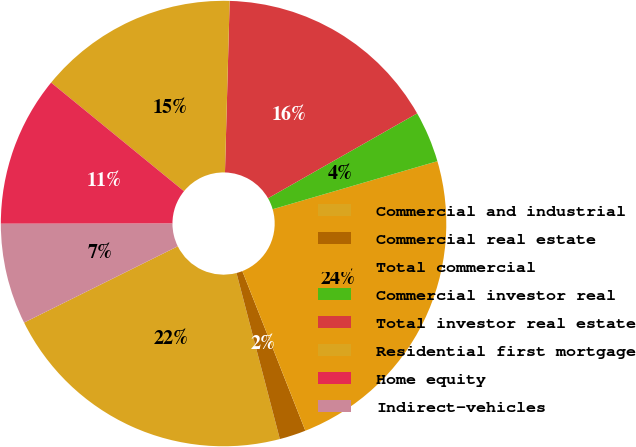Convert chart. <chart><loc_0><loc_0><loc_500><loc_500><pie_chart><fcel>Commercial and industrial<fcel>Commercial real estate<fcel>Total commercial<fcel>Commercial investor real<fcel>Total investor real estate<fcel>Residential first mortgage<fcel>Home equity<fcel>Indirect-vehicles<nl><fcel>21.73%<fcel>1.92%<fcel>23.53%<fcel>3.72%<fcel>16.33%<fcel>14.53%<fcel>10.92%<fcel>7.32%<nl></chart> 